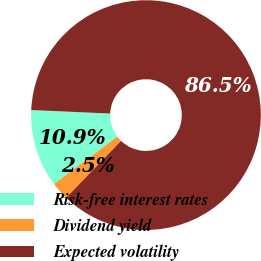Convert chart to OTSL. <chart><loc_0><loc_0><loc_500><loc_500><pie_chart><fcel>Risk-free interest rates<fcel>Dividend yield<fcel>Expected volatility<nl><fcel>10.93%<fcel>2.55%<fcel>86.52%<nl></chart> 